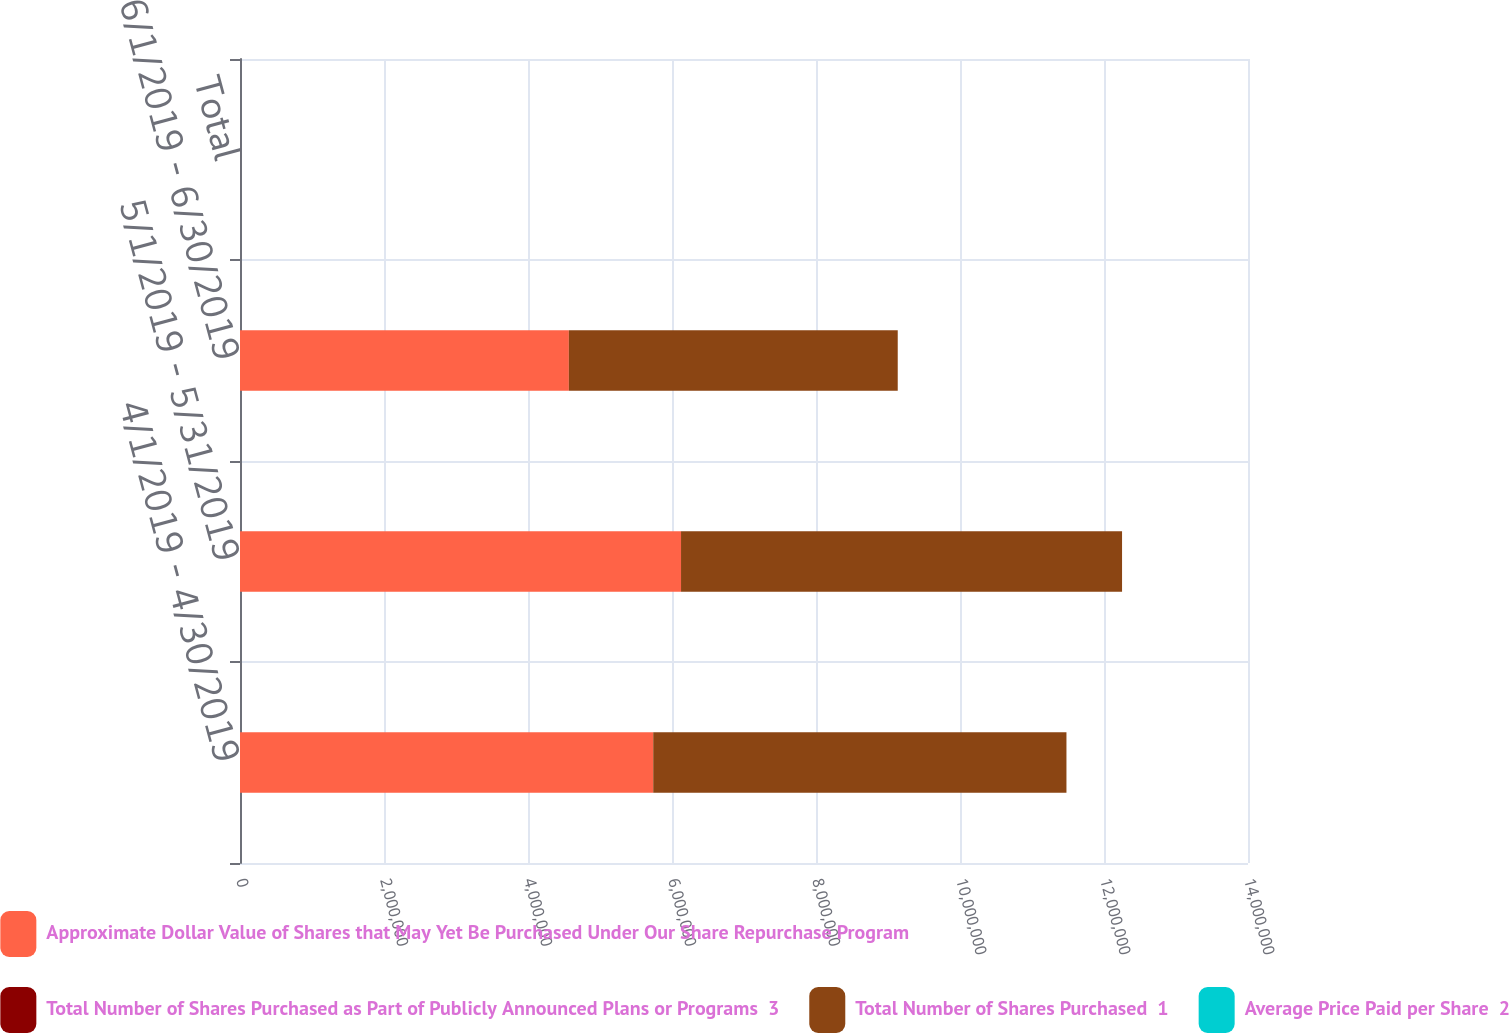Convert chart to OTSL. <chart><loc_0><loc_0><loc_500><loc_500><stacked_bar_chart><ecel><fcel>4/1/2019 - 4/30/2019<fcel>5/1/2019 - 5/31/2019<fcel>6/1/2019 - 6/30/2019<fcel>Total<nl><fcel>Approximate Dollar Value of Shares that May Yet Be Purchased Under Our Share Repurchase Program<fcel>5.73921e+06<fcel>6.1253e+06<fcel>4.56757e+06<fcel>107.985<nl><fcel>Total Number of Shares Purchased as Part of Publicly Announced Plans or Programs  3<fcel>104.54<fcel>106.12<fcel>109.47<fcel>106.5<nl><fcel>Total Number of Shares Purchased  1<fcel>5.73921e+06<fcel>6.1253e+06<fcel>4.56757e+06<fcel>107.985<nl><fcel>Average Price Paid per Share  2<fcel>3<fcel>3<fcel>3<fcel>3<nl></chart> 